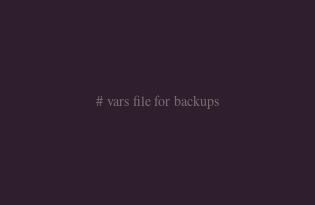Convert code to text. <code><loc_0><loc_0><loc_500><loc_500><_YAML_># vars file for backups</code> 